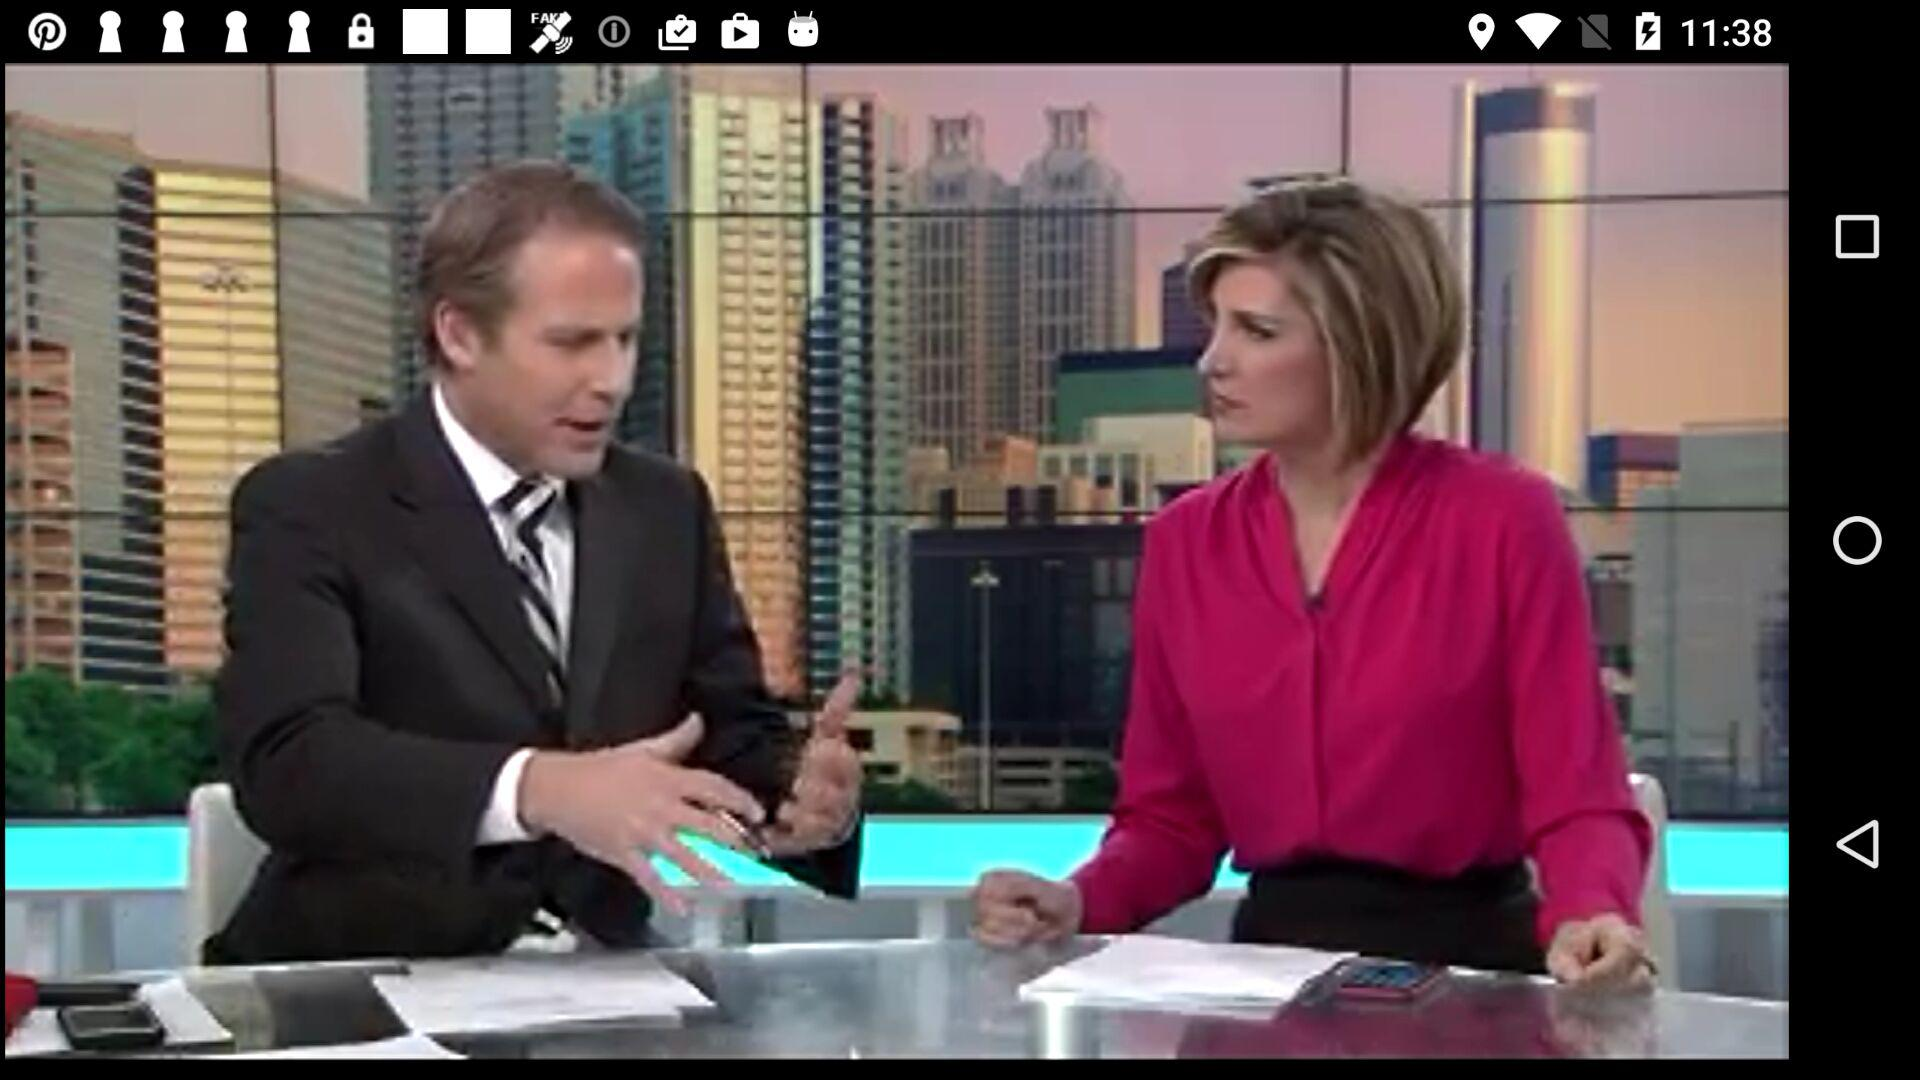How many unread notifications are there in total? There are more than 9 unread notifications in total. 